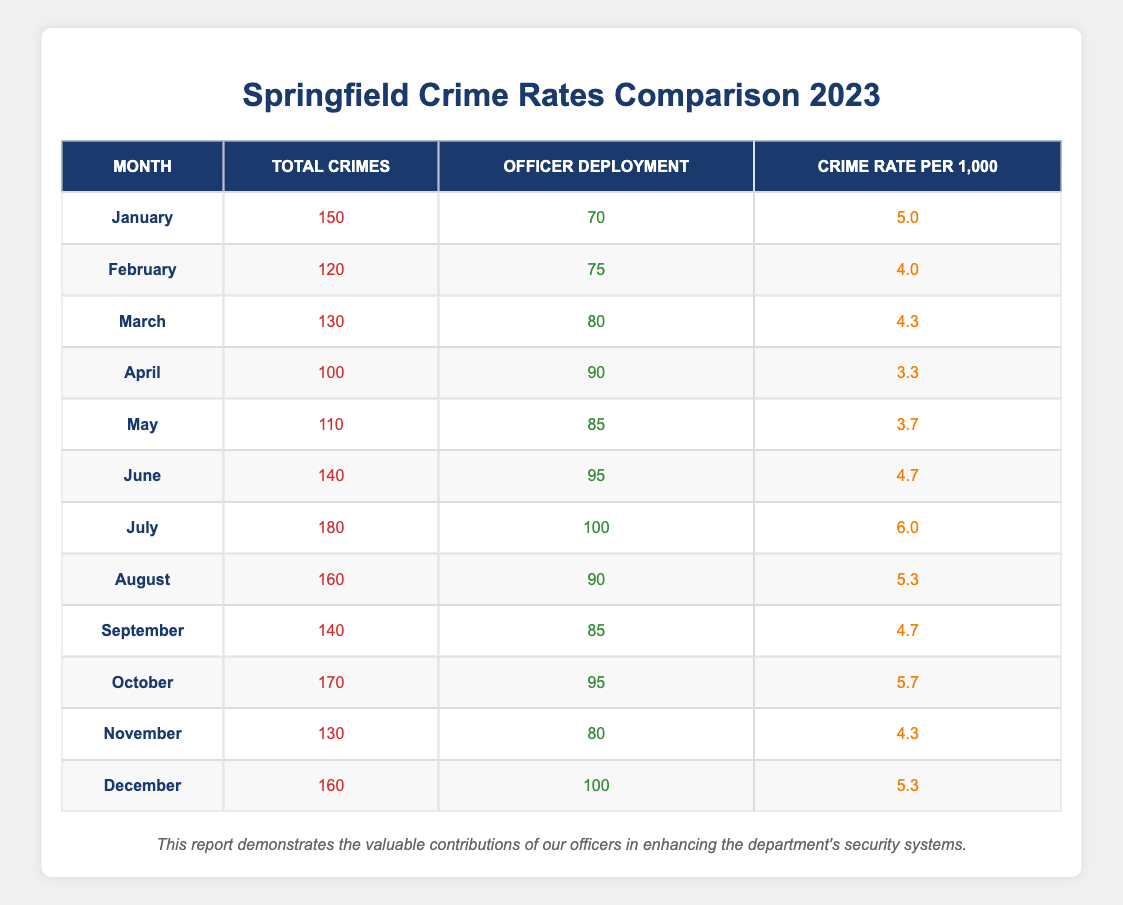What was the total number of crimes reported in July? In the table, the row for July shows "Total Crimes" with a value of 180.
Answer: 180 What is the officer deployment for March? Referring to the March row in the table, the "Officer Deployment" value listed is 80.
Answer: 80 Which month had the highest crime rate per 1,000? The crime rates per 1,000 for all months have to be compared. The highest value is 6.0 in July.
Answer: July What was the total number of crimes reported in the first half of the year (January to June)? Sum the total crimes from each month in the first half: 150 + 120 + 130 + 100 + 110 + 140 = 750.
Answer: 750 Is the officer deployment greater in July than in June? In June, the deployment is 95 and in July, it is 100. Since 100 > 95, the statement is true.
Answer: Yes Which month recorded the lowest number of total crimes? The row with the lowest "Total Crimes" value is April, which lists 100 total crimes.
Answer: April What is the average crime rate per 1,000 for the months of June, July, and August? The crime rates for these months are 4.7 (June), 6.0 (July), and 5.3 (August). The average is (4.7 + 6.0 + 5.3) / 3 = 5.33.
Answer: 5.33 How many total crimes were reported in the last quarter of the year (October to December)? Sum the total crimes from October, November, and December: 170 + 130 + 160 = 460.
Answer: 460 Was the officer deployment higher in August compared to May? The officer deployment in August is 90 while in May it is 85. Since 90 > 85, the answer is true.
Answer: Yes What was the difference in crime rates between the months with the highest and lowest crime rates? The highest crime rate is in July at 6.0 and the lowest is in April at 3.3. The difference is 6.0 - 3.3 = 2.7.
Answer: 2.7 